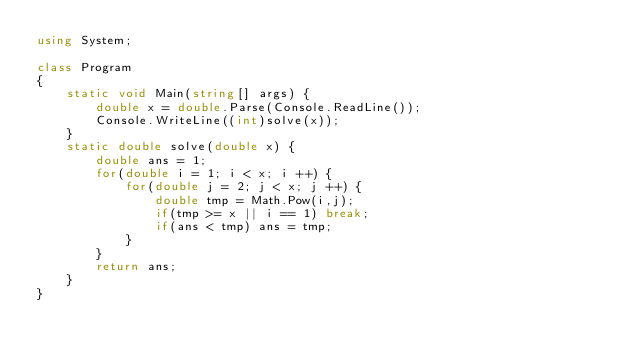<code> <loc_0><loc_0><loc_500><loc_500><_C#_>using System;

class Program
{
    static void Main(string[] args) {
        double x = double.Parse(Console.ReadLine());
        Console.WriteLine((int)solve(x));
    }
    static double solve(double x) {
        double ans = 1;
        for(double i = 1; i < x; i ++) {
            for(double j = 2; j < x; j ++) {
                double tmp = Math.Pow(i,j);
                if(tmp >= x || i == 1) break;
                if(ans < tmp) ans = tmp;
            }
        }
        return ans;
    }
}</code> 